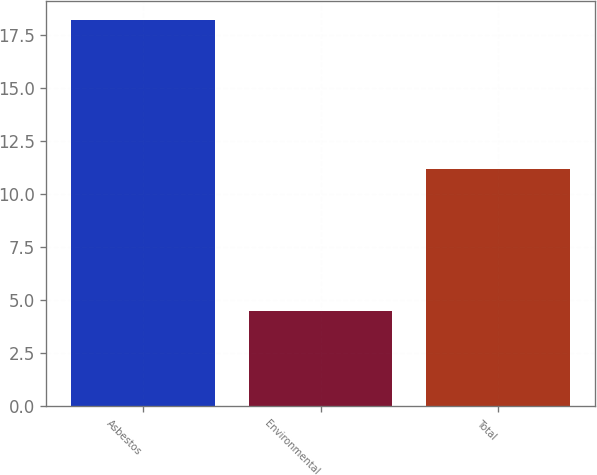Convert chart. <chart><loc_0><loc_0><loc_500><loc_500><bar_chart><fcel>Asbestos<fcel>Environmental<fcel>Total<nl><fcel>18.2<fcel>4.5<fcel>11.2<nl></chart> 